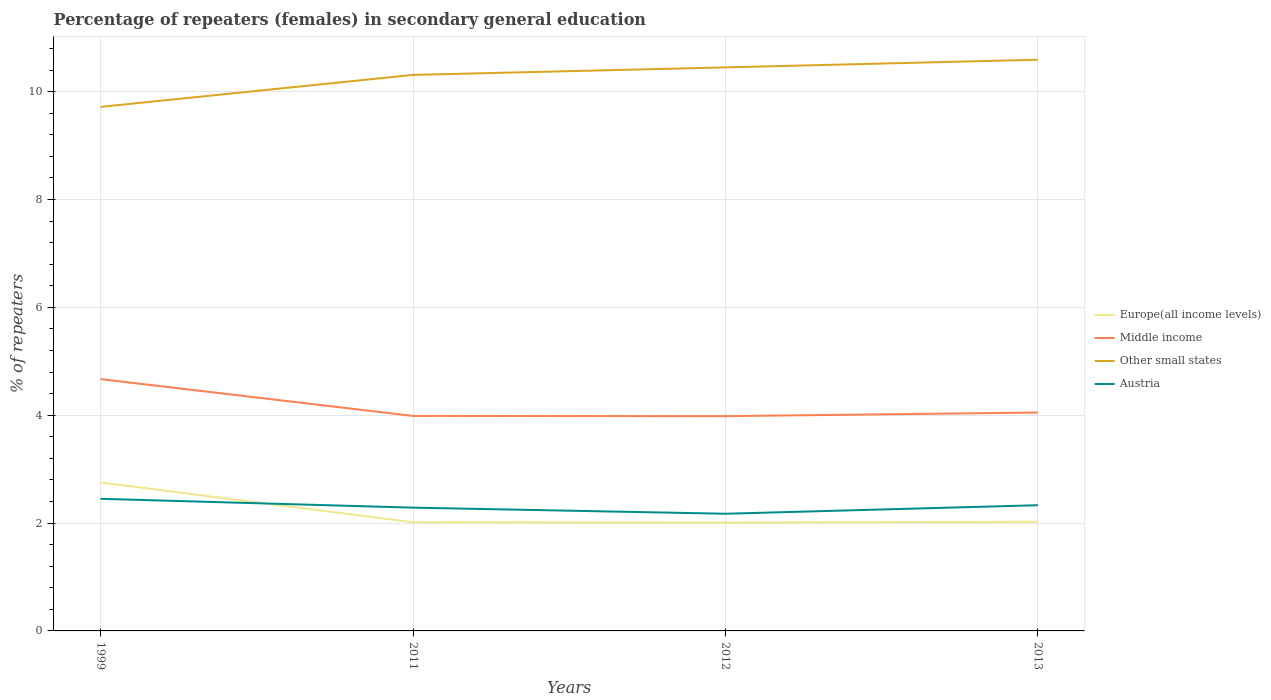How many different coloured lines are there?
Your response must be concise. 4. Does the line corresponding to Austria intersect with the line corresponding to Europe(all income levels)?
Offer a terse response. Yes. Is the number of lines equal to the number of legend labels?
Your response must be concise. Yes. Across all years, what is the maximum percentage of female repeaters in Other small states?
Offer a very short reply. 9.72. What is the total percentage of female repeaters in Other small states in the graph?
Offer a very short reply. -0.28. What is the difference between the highest and the second highest percentage of female repeaters in Middle income?
Make the answer very short. 0.69. Is the percentage of female repeaters in Other small states strictly greater than the percentage of female repeaters in Austria over the years?
Your answer should be compact. No. What is the difference between two consecutive major ticks on the Y-axis?
Offer a terse response. 2. Does the graph contain any zero values?
Provide a succinct answer. No. Where does the legend appear in the graph?
Offer a terse response. Center right. How many legend labels are there?
Your answer should be compact. 4. What is the title of the graph?
Provide a succinct answer. Percentage of repeaters (females) in secondary general education. What is the label or title of the Y-axis?
Give a very brief answer. % of repeaters. What is the % of repeaters in Europe(all income levels) in 1999?
Offer a very short reply. 2.75. What is the % of repeaters of Middle income in 1999?
Give a very brief answer. 4.67. What is the % of repeaters of Other small states in 1999?
Keep it short and to the point. 9.72. What is the % of repeaters in Austria in 1999?
Provide a short and direct response. 2.45. What is the % of repeaters in Europe(all income levels) in 2011?
Provide a succinct answer. 2.01. What is the % of repeaters in Middle income in 2011?
Make the answer very short. 3.99. What is the % of repeaters of Other small states in 2011?
Ensure brevity in your answer.  10.31. What is the % of repeaters of Austria in 2011?
Ensure brevity in your answer.  2.29. What is the % of repeaters of Europe(all income levels) in 2012?
Provide a short and direct response. 2.01. What is the % of repeaters in Middle income in 2012?
Provide a short and direct response. 3.98. What is the % of repeaters in Other small states in 2012?
Ensure brevity in your answer.  10.45. What is the % of repeaters in Austria in 2012?
Your answer should be compact. 2.17. What is the % of repeaters of Europe(all income levels) in 2013?
Provide a short and direct response. 2.02. What is the % of repeaters in Middle income in 2013?
Your answer should be very brief. 4.05. What is the % of repeaters in Other small states in 2013?
Your response must be concise. 10.59. What is the % of repeaters in Austria in 2013?
Your answer should be very brief. 2.33. Across all years, what is the maximum % of repeaters in Europe(all income levels)?
Make the answer very short. 2.75. Across all years, what is the maximum % of repeaters in Middle income?
Keep it short and to the point. 4.67. Across all years, what is the maximum % of repeaters in Other small states?
Your answer should be compact. 10.59. Across all years, what is the maximum % of repeaters in Austria?
Offer a very short reply. 2.45. Across all years, what is the minimum % of repeaters of Europe(all income levels)?
Offer a terse response. 2.01. Across all years, what is the minimum % of repeaters in Middle income?
Your answer should be compact. 3.98. Across all years, what is the minimum % of repeaters of Other small states?
Give a very brief answer. 9.72. Across all years, what is the minimum % of repeaters of Austria?
Provide a short and direct response. 2.17. What is the total % of repeaters of Europe(all income levels) in the graph?
Your answer should be compact. 8.8. What is the total % of repeaters in Middle income in the graph?
Offer a very short reply. 16.69. What is the total % of repeaters in Other small states in the graph?
Provide a short and direct response. 41.07. What is the total % of repeaters of Austria in the graph?
Your response must be concise. 9.24. What is the difference between the % of repeaters of Europe(all income levels) in 1999 and that in 2011?
Your answer should be compact. 0.74. What is the difference between the % of repeaters in Middle income in 1999 and that in 2011?
Your answer should be very brief. 0.68. What is the difference between the % of repeaters of Other small states in 1999 and that in 2011?
Give a very brief answer. -0.59. What is the difference between the % of repeaters in Austria in 1999 and that in 2011?
Provide a succinct answer. 0.16. What is the difference between the % of repeaters in Europe(all income levels) in 1999 and that in 2012?
Your answer should be compact. 0.74. What is the difference between the % of repeaters in Middle income in 1999 and that in 2012?
Keep it short and to the point. 0.69. What is the difference between the % of repeaters of Other small states in 1999 and that in 2012?
Ensure brevity in your answer.  -0.73. What is the difference between the % of repeaters of Austria in 1999 and that in 2012?
Offer a terse response. 0.28. What is the difference between the % of repeaters of Europe(all income levels) in 1999 and that in 2013?
Keep it short and to the point. 0.73. What is the difference between the % of repeaters in Middle income in 1999 and that in 2013?
Offer a terse response. 0.62. What is the difference between the % of repeaters of Other small states in 1999 and that in 2013?
Give a very brief answer. -0.87. What is the difference between the % of repeaters of Austria in 1999 and that in 2013?
Offer a very short reply. 0.12. What is the difference between the % of repeaters in Europe(all income levels) in 2011 and that in 2012?
Give a very brief answer. 0. What is the difference between the % of repeaters in Middle income in 2011 and that in 2012?
Your answer should be compact. 0. What is the difference between the % of repeaters of Other small states in 2011 and that in 2012?
Make the answer very short. -0.14. What is the difference between the % of repeaters of Austria in 2011 and that in 2012?
Offer a very short reply. 0.11. What is the difference between the % of repeaters in Europe(all income levels) in 2011 and that in 2013?
Make the answer very short. -0.01. What is the difference between the % of repeaters of Middle income in 2011 and that in 2013?
Offer a very short reply. -0.06. What is the difference between the % of repeaters in Other small states in 2011 and that in 2013?
Provide a succinct answer. -0.28. What is the difference between the % of repeaters of Austria in 2011 and that in 2013?
Provide a short and direct response. -0.05. What is the difference between the % of repeaters in Europe(all income levels) in 2012 and that in 2013?
Give a very brief answer. -0.01. What is the difference between the % of repeaters in Middle income in 2012 and that in 2013?
Ensure brevity in your answer.  -0.07. What is the difference between the % of repeaters in Other small states in 2012 and that in 2013?
Your answer should be compact. -0.14. What is the difference between the % of repeaters in Austria in 2012 and that in 2013?
Make the answer very short. -0.16. What is the difference between the % of repeaters in Europe(all income levels) in 1999 and the % of repeaters in Middle income in 2011?
Make the answer very short. -1.23. What is the difference between the % of repeaters of Europe(all income levels) in 1999 and the % of repeaters of Other small states in 2011?
Ensure brevity in your answer.  -7.56. What is the difference between the % of repeaters in Europe(all income levels) in 1999 and the % of repeaters in Austria in 2011?
Ensure brevity in your answer.  0.47. What is the difference between the % of repeaters of Middle income in 1999 and the % of repeaters of Other small states in 2011?
Provide a short and direct response. -5.64. What is the difference between the % of repeaters of Middle income in 1999 and the % of repeaters of Austria in 2011?
Provide a short and direct response. 2.38. What is the difference between the % of repeaters in Other small states in 1999 and the % of repeaters in Austria in 2011?
Provide a succinct answer. 7.43. What is the difference between the % of repeaters of Europe(all income levels) in 1999 and the % of repeaters of Middle income in 2012?
Offer a very short reply. -1.23. What is the difference between the % of repeaters of Europe(all income levels) in 1999 and the % of repeaters of Other small states in 2012?
Your answer should be very brief. -7.7. What is the difference between the % of repeaters of Europe(all income levels) in 1999 and the % of repeaters of Austria in 2012?
Your response must be concise. 0.58. What is the difference between the % of repeaters of Middle income in 1999 and the % of repeaters of Other small states in 2012?
Make the answer very short. -5.78. What is the difference between the % of repeaters in Middle income in 1999 and the % of repeaters in Austria in 2012?
Your answer should be very brief. 2.5. What is the difference between the % of repeaters in Other small states in 1999 and the % of repeaters in Austria in 2012?
Give a very brief answer. 7.55. What is the difference between the % of repeaters of Europe(all income levels) in 1999 and the % of repeaters of Middle income in 2013?
Ensure brevity in your answer.  -1.3. What is the difference between the % of repeaters in Europe(all income levels) in 1999 and the % of repeaters in Other small states in 2013?
Give a very brief answer. -7.84. What is the difference between the % of repeaters of Europe(all income levels) in 1999 and the % of repeaters of Austria in 2013?
Provide a succinct answer. 0.42. What is the difference between the % of repeaters in Middle income in 1999 and the % of repeaters in Other small states in 2013?
Give a very brief answer. -5.92. What is the difference between the % of repeaters in Middle income in 1999 and the % of repeaters in Austria in 2013?
Offer a terse response. 2.34. What is the difference between the % of repeaters of Other small states in 1999 and the % of repeaters of Austria in 2013?
Offer a very short reply. 7.39. What is the difference between the % of repeaters of Europe(all income levels) in 2011 and the % of repeaters of Middle income in 2012?
Provide a short and direct response. -1.97. What is the difference between the % of repeaters in Europe(all income levels) in 2011 and the % of repeaters in Other small states in 2012?
Your response must be concise. -8.44. What is the difference between the % of repeaters of Europe(all income levels) in 2011 and the % of repeaters of Austria in 2012?
Your response must be concise. -0.16. What is the difference between the % of repeaters in Middle income in 2011 and the % of repeaters in Other small states in 2012?
Offer a terse response. -6.46. What is the difference between the % of repeaters of Middle income in 2011 and the % of repeaters of Austria in 2012?
Ensure brevity in your answer.  1.81. What is the difference between the % of repeaters in Other small states in 2011 and the % of repeaters in Austria in 2012?
Your answer should be compact. 8.14. What is the difference between the % of repeaters in Europe(all income levels) in 2011 and the % of repeaters in Middle income in 2013?
Keep it short and to the point. -2.03. What is the difference between the % of repeaters of Europe(all income levels) in 2011 and the % of repeaters of Other small states in 2013?
Give a very brief answer. -8.58. What is the difference between the % of repeaters of Europe(all income levels) in 2011 and the % of repeaters of Austria in 2013?
Your response must be concise. -0.32. What is the difference between the % of repeaters of Middle income in 2011 and the % of repeaters of Other small states in 2013?
Make the answer very short. -6.61. What is the difference between the % of repeaters in Middle income in 2011 and the % of repeaters in Austria in 2013?
Make the answer very short. 1.66. What is the difference between the % of repeaters of Other small states in 2011 and the % of repeaters of Austria in 2013?
Offer a terse response. 7.98. What is the difference between the % of repeaters in Europe(all income levels) in 2012 and the % of repeaters in Middle income in 2013?
Ensure brevity in your answer.  -2.04. What is the difference between the % of repeaters in Europe(all income levels) in 2012 and the % of repeaters in Other small states in 2013?
Offer a terse response. -8.58. What is the difference between the % of repeaters in Europe(all income levels) in 2012 and the % of repeaters in Austria in 2013?
Offer a very short reply. -0.32. What is the difference between the % of repeaters in Middle income in 2012 and the % of repeaters in Other small states in 2013?
Your answer should be very brief. -6.61. What is the difference between the % of repeaters in Middle income in 2012 and the % of repeaters in Austria in 2013?
Offer a very short reply. 1.65. What is the difference between the % of repeaters of Other small states in 2012 and the % of repeaters of Austria in 2013?
Your answer should be compact. 8.12. What is the average % of repeaters of Europe(all income levels) per year?
Your response must be concise. 2.2. What is the average % of repeaters in Middle income per year?
Make the answer very short. 4.17. What is the average % of repeaters in Other small states per year?
Your response must be concise. 10.27. What is the average % of repeaters in Austria per year?
Provide a succinct answer. 2.31. In the year 1999, what is the difference between the % of repeaters in Europe(all income levels) and % of repeaters in Middle income?
Offer a very short reply. -1.92. In the year 1999, what is the difference between the % of repeaters in Europe(all income levels) and % of repeaters in Other small states?
Ensure brevity in your answer.  -6.96. In the year 1999, what is the difference between the % of repeaters of Europe(all income levels) and % of repeaters of Austria?
Provide a short and direct response. 0.3. In the year 1999, what is the difference between the % of repeaters in Middle income and % of repeaters in Other small states?
Give a very brief answer. -5.05. In the year 1999, what is the difference between the % of repeaters in Middle income and % of repeaters in Austria?
Provide a short and direct response. 2.22. In the year 1999, what is the difference between the % of repeaters in Other small states and % of repeaters in Austria?
Your answer should be very brief. 7.27. In the year 2011, what is the difference between the % of repeaters of Europe(all income levels) and % of repeaters of Middle income?
Your answer should be compact. -1.97. In the year 2011, what is the difference between the % of repeaters in Europe(all income levels) and % of repeaters in Other small states?
Keep it short and to the point. -8.3. In the year 2011, what is the difference between the % of repeaters of Europe(all income levels) and % of repeaters of Austria?
Ensure brevity in your answer.  -0.27. In the year 2011, what is the difference between the % of repeaters of Middle income and % of repeaters of Other small states?
Your response must be concise. -6.32. In the year 2011, what is the difference between the % of repeaters of Middle income and % of repeaters of Austria?
Keep it short and to the point. 1.7. In the year 2011, what is the difference between the % of repeaters in Other small states and % of repeaters in Austria?
Provide a succinct answer. 8.02. In the year 2012, what is the difference between the % of repeaters of Europe(all income levels) and % of repeaters of Middle income?
Ensure brevity in your answer.  -1.97. In the year 2012, what is the difference between the % of repeaters of Europe(all income levels) and % of repeaters of Other small states?
Make the answer very short. -8.44. In the year 2012, what is the difference between the % of repeaters of Europe(all income levels) and % of repeaters of Austria?
Your response must be concise. -0.16. In the year 2012, what is the difference between the % of repeaters of Middle income and % of repeaters of Other small states?
Give a very brief answer. -6.47. In the year 2012, what is the difference between the % of repeaters in Middle income and % of repeaters in Austria?
Offer a terse response. 1.81. In the year 2012, what is the difference between the % of repeaters of Other small states and % of repeaters of Austria?
Give a very brief answer. 8.28. In the year 2013, what is the difference between the % of repeaters of Europe(all income levels) and % of repeaters of Middle income?
Offer a terse response. -2.03. In the year 2013, what is the difference between the % of repeaters of Europe(all income levels) and % of repeaters of Other small states?
Offer a terse response. -8.57. In the year 2013, what is the difference between the % of repeaters in Europe(all income levels) and % of repeaters in Austria?
Provide a short and direct response. -0.31. In the year 2013, what is the difference between the % of repeaters of Middle income and % of repeaters of Other small states?
Ensure brevity in your answer.  -6.54. In the year 2013, what is the difference between the % of repeaters in Middle income and % of repeaters in Austria?
Offer a terse response. 1.72. In the year 2013, what is the difference between the % of repeaters of Other small states and % of repeaters of Austria?
Provide a succinct answer. 8.26. What is the ratio of the % of repeaters of Europe(all income levels) in 1999 to that in 2011?
Provide a short and direct response. 1.37. What is the ratio of the % of repeaters of Middle income in 1999 to that in 2011?
Provide a short and direct response. 1.17. What is the ratio of the % of repeaters in Other small states in 1999 to that in 2011?
Your answer should be very brief. 0.94. What is the ratio of the % of repeaters of Austria in 1999 to that in 2011?
Keep it short and to the point. 1.07. What is the ratio of the % of repeaters in Europe(all income levels) in 1999 to that in 2012?
Keep it short and to the point. 1.37. What is the ratio of the % of repeaters of Middle income in 1999 to that in 2012?
Provide a succinct answer. 1.17. What is the ratio of the % of repeaters in Other small states in 1999 to that in 2012?
Your response must be concise. 0.93. What is the ratio of the % of repeaters in Austria in 1999 to that in 2012?
Make the answer very short. 1.13. What is the ratio of the % of repeaters of Europe(all income levels) in 1999 to that in 2013?
Your answer should be compact. 1.36. What is the ratio of the % of repeaters of Middle income in 1999 to that in 2013?
Provide a succinct answer. 1.15. What is the ratio of the % of repeaters in Other small states in 1999 to that in 2013?
Your answer should be compact. 0.92. What is the ratio of the % of repeaters in Austria in 1999 to that in 2013?
Make the answer very short. 1.05. What is the ratio of the % of repeaters of Europe(all income levels) in 2011 to that in 2012?
Your answer should be very brief. 1. What is the ratio of the % of repeaters of Middle income in 2011 to that in 2012?
Your answer should be very brief. 1. What is the ratio of the % of repeaters of Other small states in 2011 to that in 2012?
Make the answer very short. 0.99. What is the ratio of the % of repeaters of Austria in 2011 to that in 2012?
Provide a short and direct response. 1.05. What is the ratio of the % of repeaters in Middle income in 2011 to that in 2013?
Your answer should be very brief. 0.98. What is the ratio of the % of repeaters in Other small states in 2011 to that in 2013?
Ensure brevity in your answer.  0.97. What is the ratio of the % of repeaters in Austria in 2011 to that in 2013?
Offer a terse response. 0.98. What is the ratio of the % of repeaters of Europe(all income levels) in 2012 to that in 2013?
Your answer should be very brief. 0.99. What is the ratio of the % of repeaters in Middle income in 2012 to that in 2013?
Your answer should be very brief. 0.98. What is the ratio of the % of repeaters of Other small states in 2012 to that in 2013?
Provide a succinct answer. 0.99. What is the ratio of the % of repeaters in Austria in 2012 to that in 2013?
Your answer should be very brief. 0.93. What is the difference between the highest and the second highest % of repeaters of Europe(all income levels)?
Keep it short and to the point. 0.73. What is the difference between the highest and the second highest % of repeaters in Middle income?
Keep it short and to the point. 0.62. What is the difference between the highest and the second highest % of repeaters of Other small states?
Your answer should be very brief. 0.14. What is the difference between the highest and the second highest % of repeaters in Austria?
Your response must be concise. 0.12. What is the difference between the highest and the lowest % of repeaters in Europe(all income levels)?
Provide a succinct answer. 0.74. What is the difference between the highest and the lowest % of repeaters of Middle income?
Offer a terse response. 0.69. What is the difference between the highest and the lowest % of repeaters of Other small states?
Ensure brevity in your answer.  0.87. What is the difference between the highest and the lowest % of repeaters in Austria?
Your answer should be very brief. 0.28. 